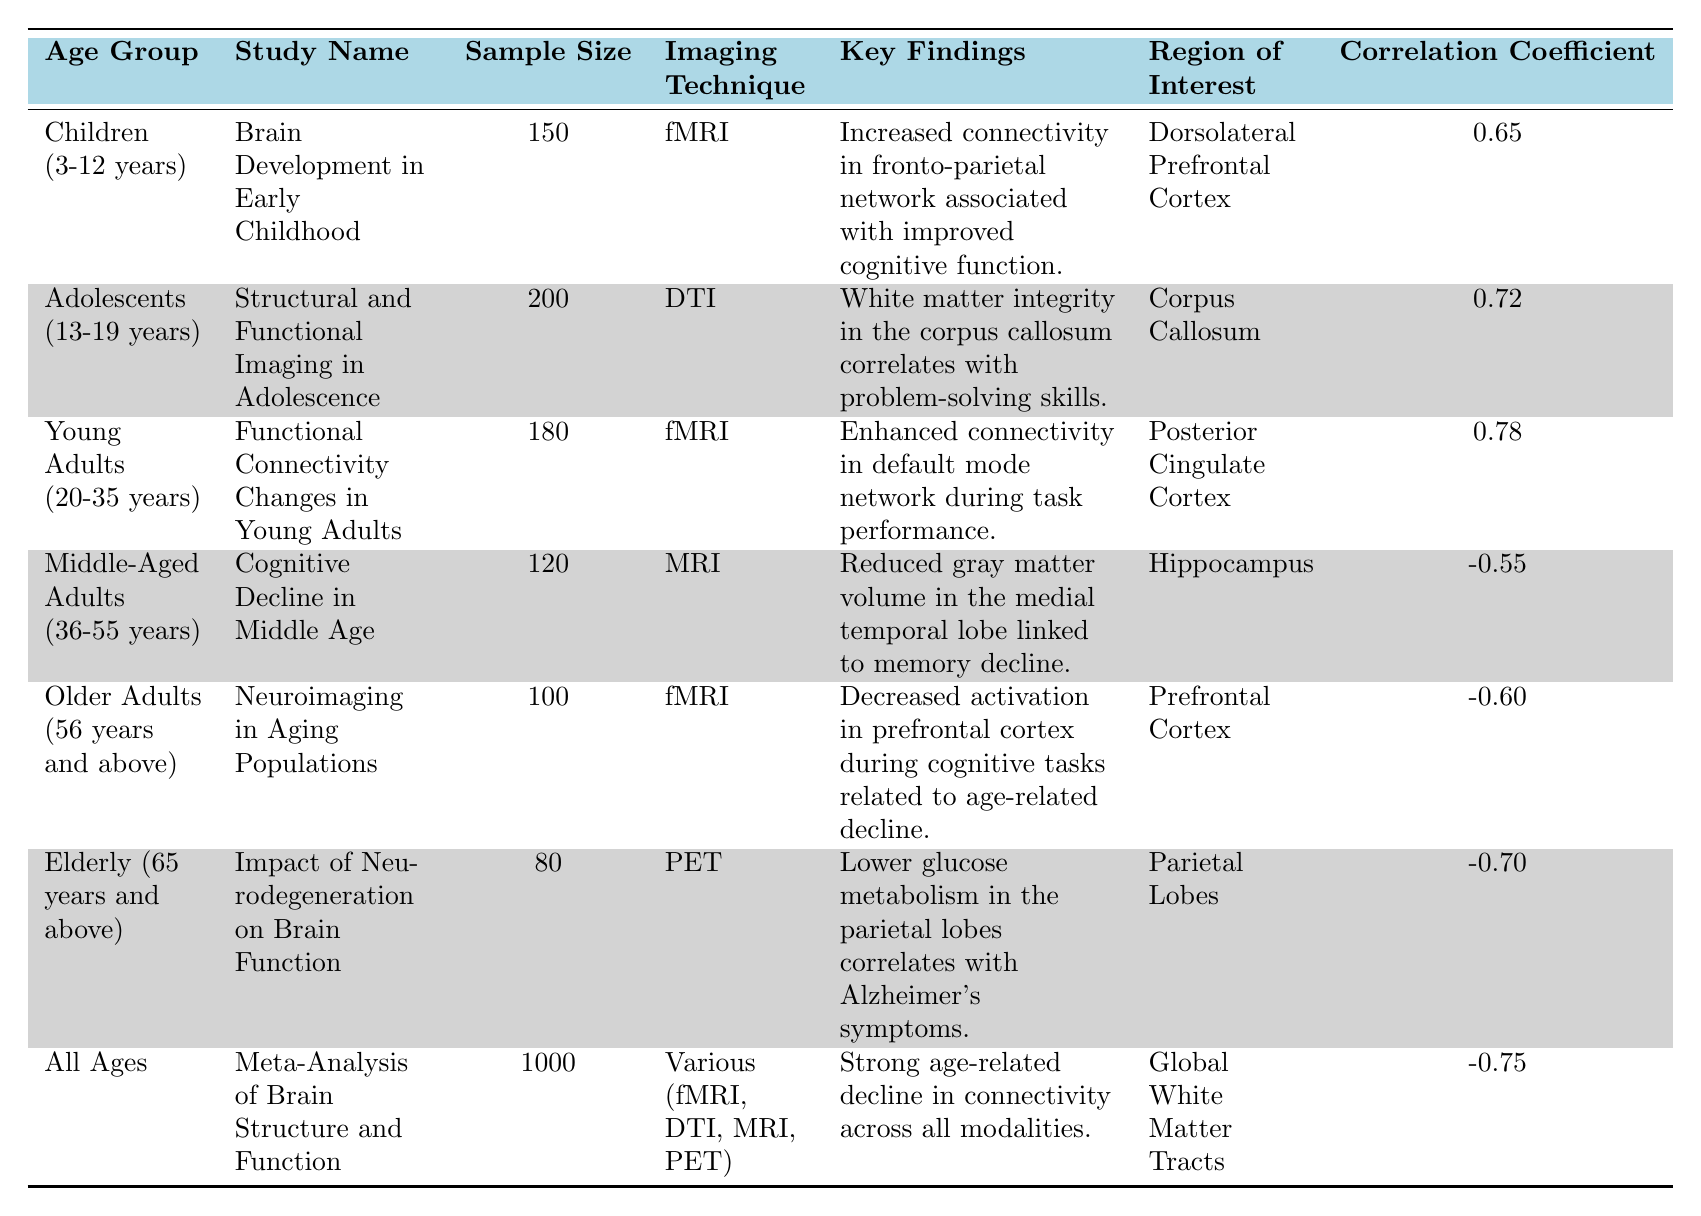What imaging technique was used in the study for children aged 3-12 years? The table specifies that the imaging technique for children in the "Brain Development in Early Childhood" study is fMRI.
Answer: fMRI What is the key finding related to the Young Adults age group? In the "Functional Connectivity Changes in Young Adults" study, the key finding is that there is enhanced connectivity in the default mode network during task performance.
Answer: Enhanced connectivity in the default mode network during task performance What is the correlation coefficient for Adolescents (13-19 years)? The table indicates that for adolescents, the correlation coefficient is 0.72 according to the study on structural and functional imaging.
Answer: 0.72 Which age group has a correlation coefficient below zero and what does it indicate? The Middle-Aged Adults, Older Adults, and Elderly groups have correlation coefficients below zero: -0.55, -0.60, and -0.70 respectively. This indicates a negative correlation between brain structure/function and cognitive performance or health outcomes.
Answer: Yes What is the average correlation coefficient for all age groups listed? To calculate the average, we sum the correlation coefficients (0.65 + 0.72 + 0.78 - 0.55 - 0.60 - 0.70 - 0.75 = -0.45) and divide by the total number of age groups (7), resulting in an average of -0.0643 rounded to -0.06.
Answer: -0.06 Which age group showed reduced gray matter volume associated with memory decline? The "Cognitive Decline in Middle Age" study for Middle-Aged Adults highlights reduced gray matter volume in the medial temporal lobe linked to memory decline.
Answer: Middle-Aged Adults How many studies used fMRI as the imaging technique? In the table, there are three studies that used fMRI: one for Children, one for Young Adults, and one for Older Adults.
Answer: 3 Is there a notable finding regarding white matter integrity in adolescents? Yes, the key finding indicates that white matter integrity in the corpus callosum correlates with problem-solving skills in adolescents.
Answer: Yes What age group has the largest sample size in the studies? The "Meta-Analysis of Brain Structure and Function" study has the largest sample size of 1000 participants for all ages.
Answer: All Ages What trend is observed in correlation coefficients as age increases from Children to Elderly? As the age increases, the correlation coefficients trend from positive values in younger age groups to increasingly negative values in older age groups, indicating a decline in brain function and structure.
Answer: Negative trend with age increase Which region of interest has a correlation of 0.65, and what does this indicate? The Dorsolateral Prefrontal Cortex has a correlation of 0.65 in the Children age group study, indicating a moderate positive relationship between connectivity in this region and cognitive function.
Answer: Dorsolateral Prefrontal Cortex, moderate positive relationship 